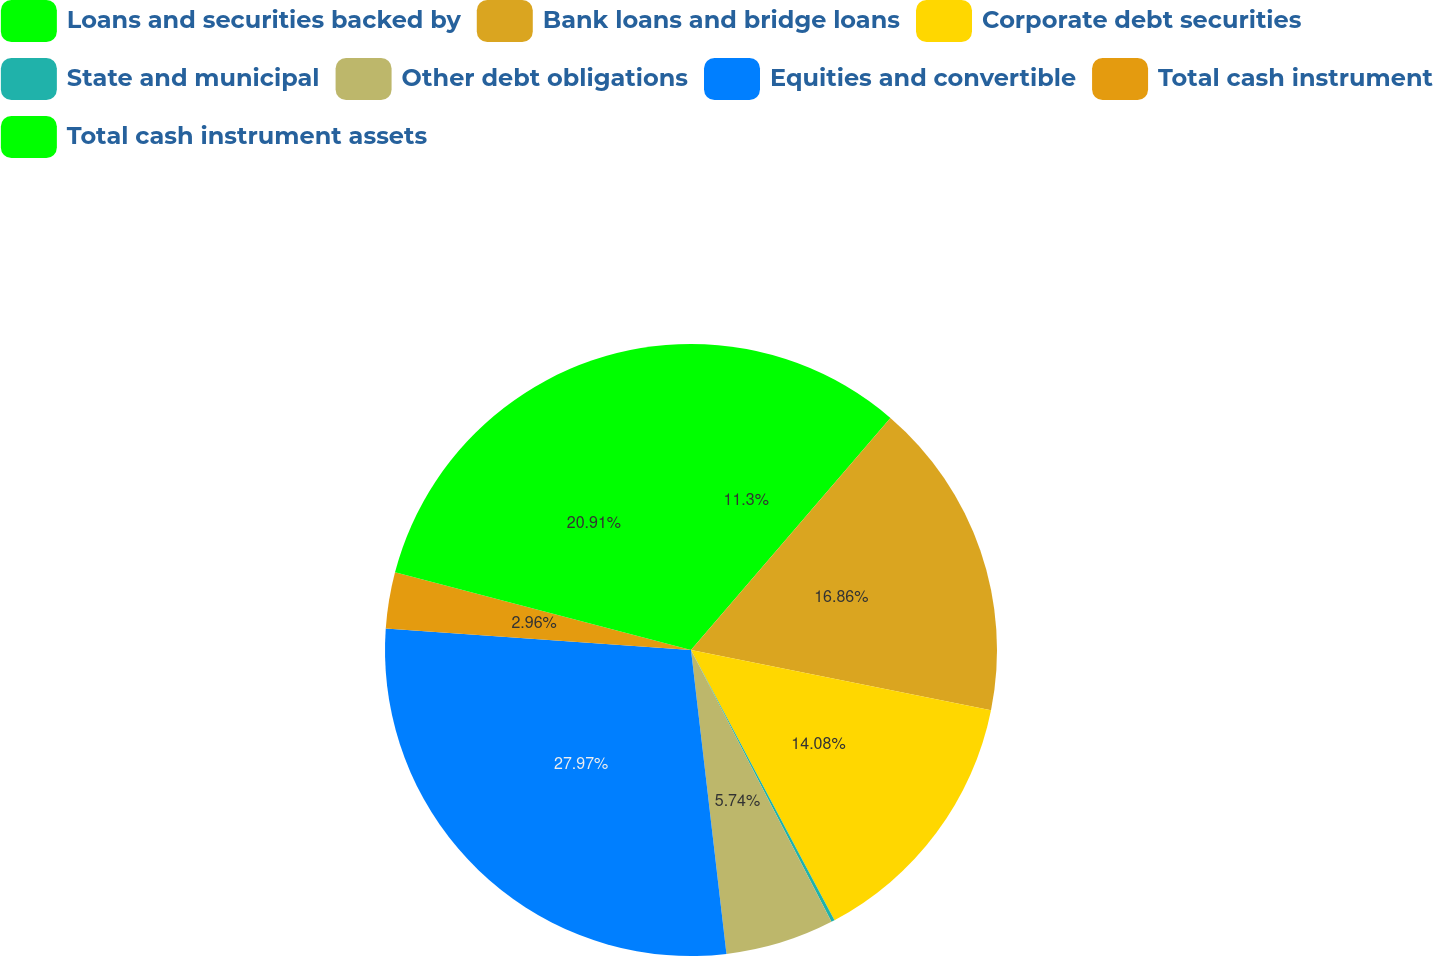Convert chart to OTSL. <chart><loc_0><loc_0><loc_500><loc_500><pie_chart><fcel>Loans and securities backed by<fcel>Bank loans and bridge loans<fcel>Corporate debt securities<fcel>State and municipal<fcel>Other debt obligations<fcel>Equities and convertible<fcel>Total cash instrument<fcel>Total cash instrument assets<nl><fcel>11.3%<fcel>16.86%<fcel>14.08%<fcel>0.18%<fcel>5.74%<fcel>27.98%<fcel>2.96%<fcel>20.92%<nl></chart> 